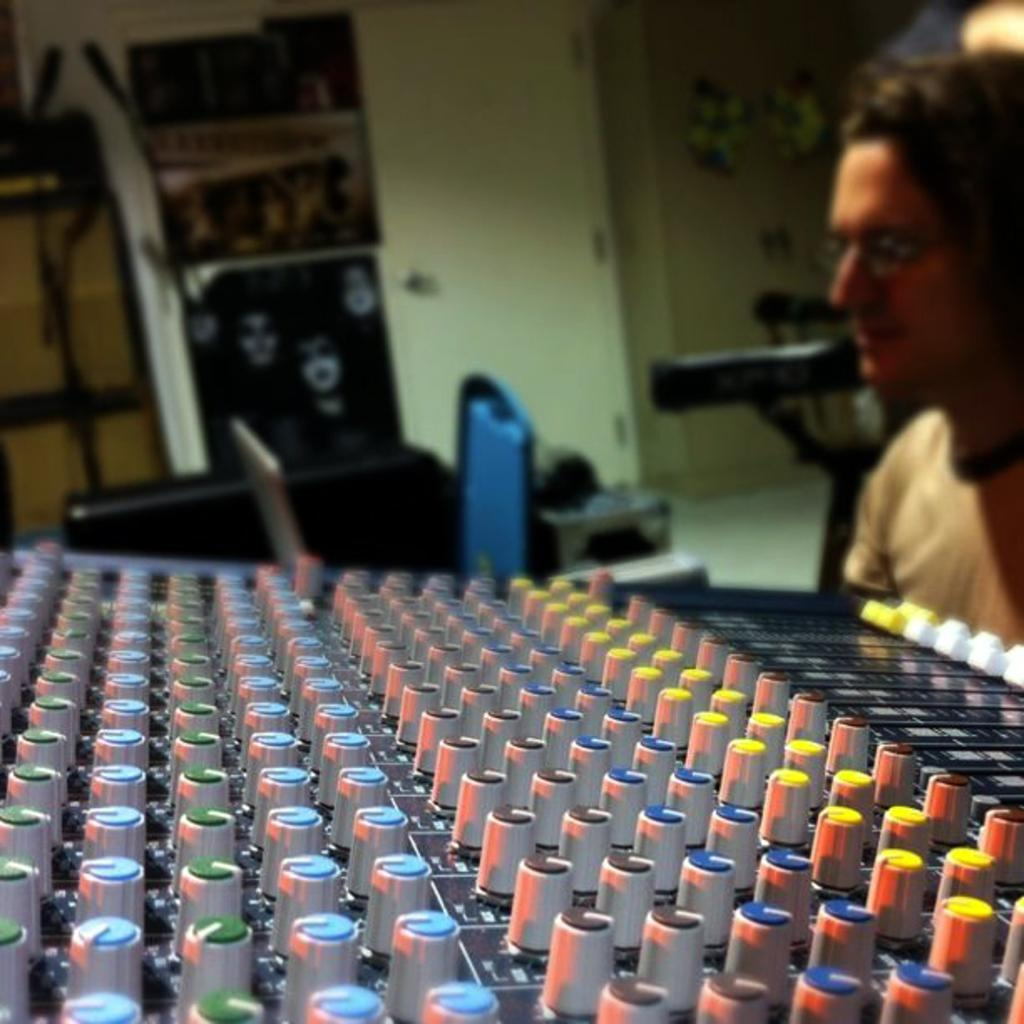What is the main object in the image? There is an electronic device in the image. Can you describe the person in the image? There is a person in the image. What else can be seen in the background of the image? There are a few objects in the background of the image. How would you describe the background of the image? The background of the image is blurry. What type of treatment is the person receiving from the electronic device in the image? There is no indication in the image that the person is receiving any treatment from the electronic device. 